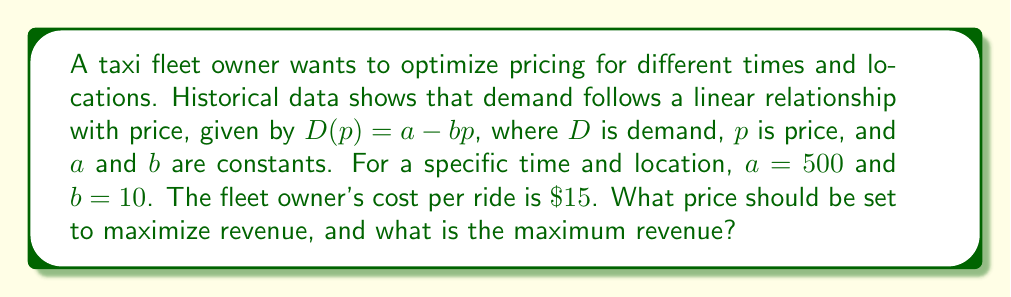Help me with this question. 1) Revenue (R) is given by price multiplied by demand:
   $R = p \cdot D(p) = p(a - bp) = ap - bp^2$

2) Substitute the given values:
   $R = 500p - 10p^2$

3) To find the maximum revenue, differentiate R with respect to p and set it to zero:
   $$\frac{dR}{dp} = 500 - 20p = 0$$

4) Solve for p:
   $500 - 20p = 0$
   $20p = 500$
   $p = 25$

5) Verify this is a maximum by checking the second derivative is negative:
   $$\frac{d^2R}{dp^2} = -20 < 0$$

6) Calculate the maximum revenue:
   $R = 500(25) - 10(25)^2 = 12500 - 6250 = 6250$

7) Check if this price is above the cost per ride ($15):
   $25 > 15$, so this price is viable.

Therefore, the optimal price is $25 per ride, resulting in a maximum revenue of $6250.
Answer: $25 per ride; $6250 maximum revenue 